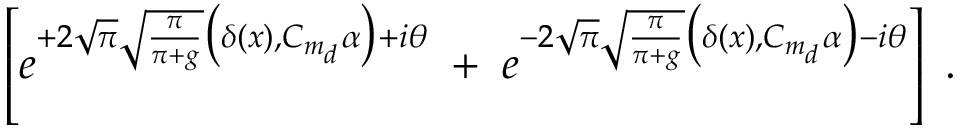Convert formula to latex. <formula><loc_0><loc_0><loc_500><loc_500>\left [ e ^ { + 2 \sqrt { \pi } \sqrt { \frac { \pi } { \pi + g } } \left ( \delta ( x ) , C _ { m _ { d } } \alpha \right ) + i \theta } \, + \, e ^ { - 2 \sqrt { \pi } \sqrt { \frac { \pi } { \pi + g } } \left ( \delta ( x ) , C _ { m _ { d } } \alpha \right ) - i \theta } \right ] \, .</formula> 